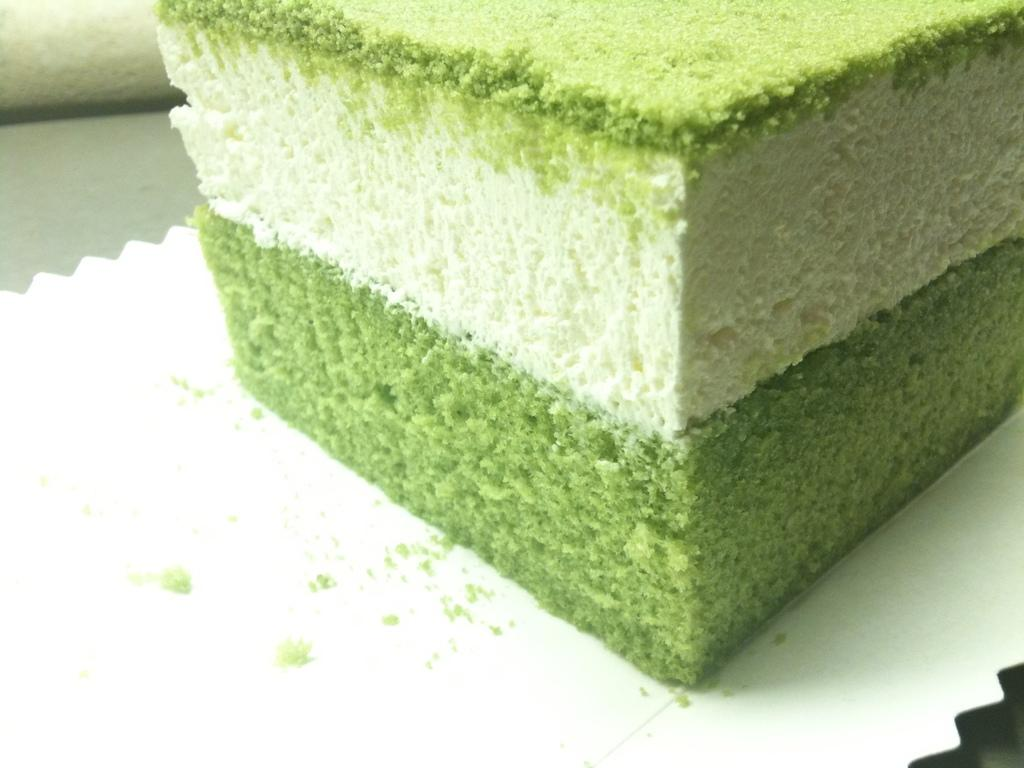What is the main subject of the image? There is a piece of cake in the image. Can you describe the cake in the image? The image shows a piece of cake, but it does not provide any details about its appearance or flavor. Is there anything else in the image besides the cake? The facts provided do not mention any other objects or subjects in the image. What type of frog can be seen sitting on top of the cake in the image? There is no frog present in the image; it only features a piece of cake. 